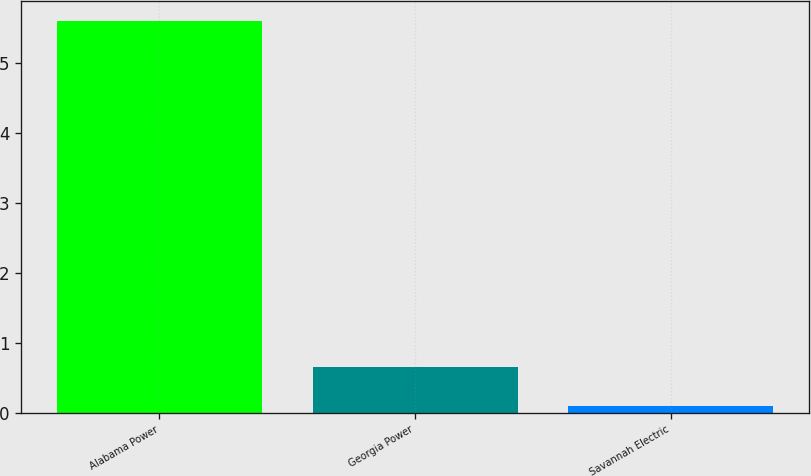<chart> <loc_0><loc_0><loc_500><loc_500><bar_chart><fcel>Alabama Power<fcel>Georgia Power<fcel>Savannah Electric<nl><fcel>5.6<fcel>0.65<fcel>0.1<nl></chart> 